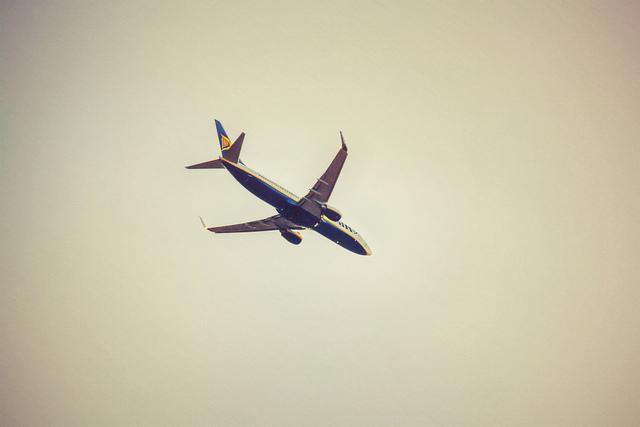What is the color of the sky?
Be succinct. Gray. What color is the sky?
Keep it brief. Gray. Does the image of the plane in the sky look realistic?
Be succinct. Yes. How many engines are on the planes?
Answer briefly. 2. What is in the sky?
Be succinct. Airplane. Are these military planes?
Answer briefly. No. How many planes?
Write a very short answer. 1. 